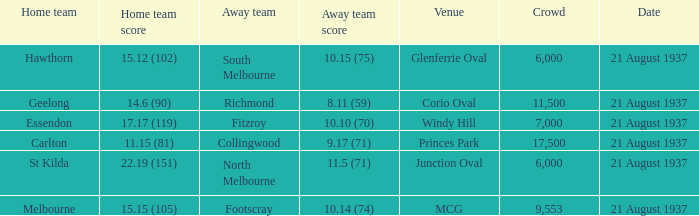Where did Richmond play? Corio Oval. 